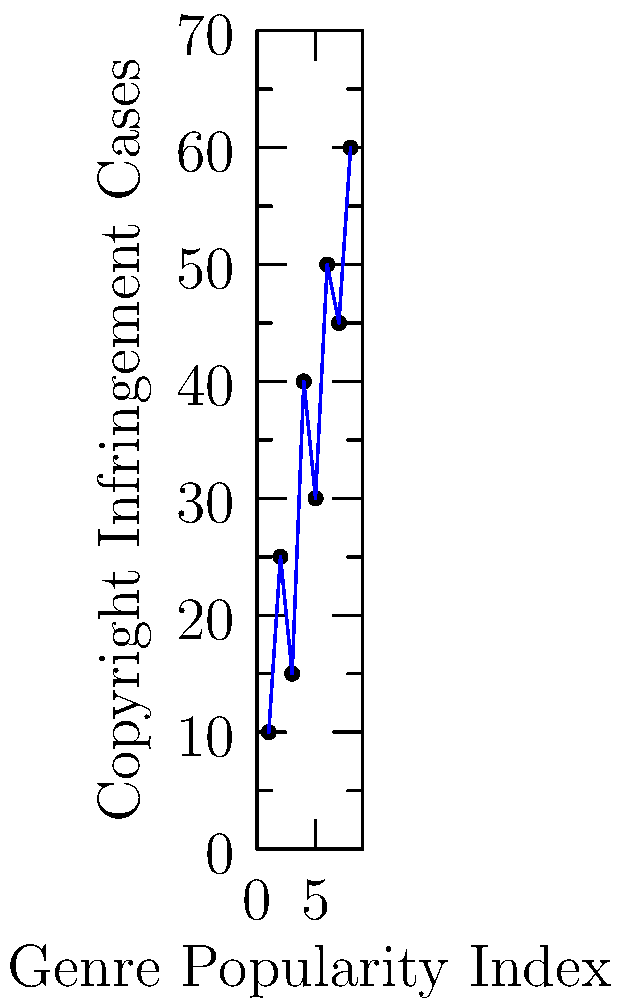Analyze the scatter plot showing the relationship between music genre popularity and copyright infringement cases. What does this trend suggest about the impact of current copyright laws on musical creativity and innovation? To analyze the scatter plot and its implications for copyright laws and musical creativity:

1. Observe the general trend: As the genre popularity index increases, the number of copyright infringement cases also tends to increase.

2. Calculate the correlation:
   - The plot shows a positive correlation between genre popularity and copyright infringement cases.
   - This suggests that more popular genres face more legal challenges related to copyright.

3. Interpret the trend:
   - More popular genres likely have more artists creating similar content, increasing the chances of perceived infringement.
   - Higher stakes in popular genres may lead to more aggressive copyright enforcement.

4. Consider the implications for creativity:
   - The increasing number of infringement cases in popular genres might discourage artists from experimenting or building upon existing works.
   - This trend could lead to a "chilling effect" where artists avoid certain creative choices to prevent potential lawsuits.

5. Reflect on copyright law's impact:
   - The current copyright system may be overly restrictive, especially for popular genres.
   - This could stifle innovation by limiting the ability of artists to draw inspiration from or reinterpret existing works.

6. Think about potential reforms:
   - The data suggests a need for more flexible copyright laws that balance protection with fostering creativity.
   - Reforms could include expanding fair use doctrines or implementing compulsory licensing systems for certain types of musical borrowing.

The trend shown in the scatter plot supports the argument that current copyright laws may be hindering musical creativity and innovation, particularly in popular genres.
Answer: The positive correlation suggests current copyright laws may stifle creativity in popular genres by increasing legal risks for artists. 